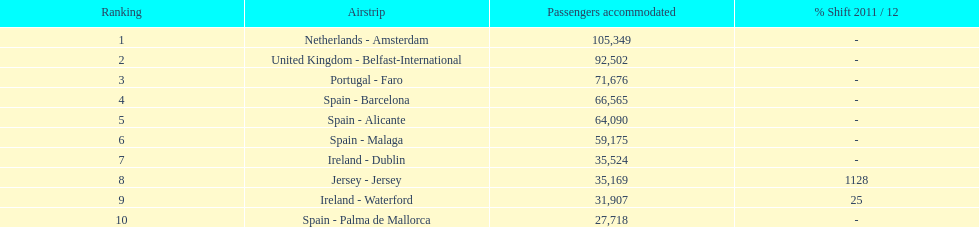Which airport had more passengers handled than the united kingdom? Netherlands - Amsterdam. 